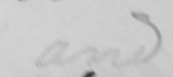What is written in this line of handwriting? and 